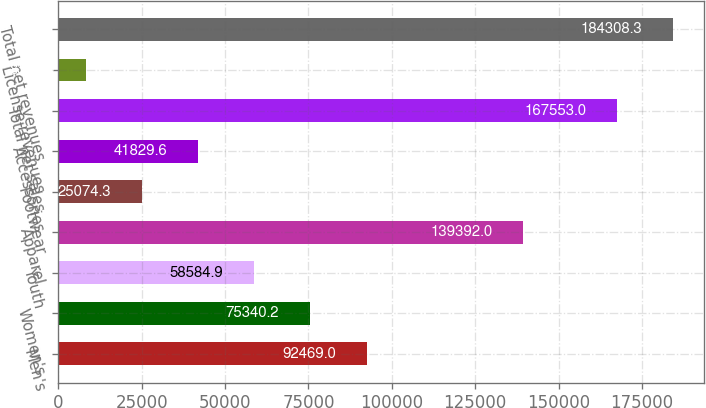Convert chart to OTSL. <chart><loc_0><loc_0><loc_500><loc_500><bar_chart><fcel>Men's<fcel>Women's<fcel>Youth<fcel>Apparel<fcel>Footwear<fcel>Accessories<fcel>Total net sales<fcel>License revenues<fcel>Total net revenues<nl><fcel>92469<fcel>75340.2<fcel>58584.9<fcel>139392<fcel>25074.3<fcel>41829.6<fcel>167553<fcel>8319<fcel>184308<nl></chart> 